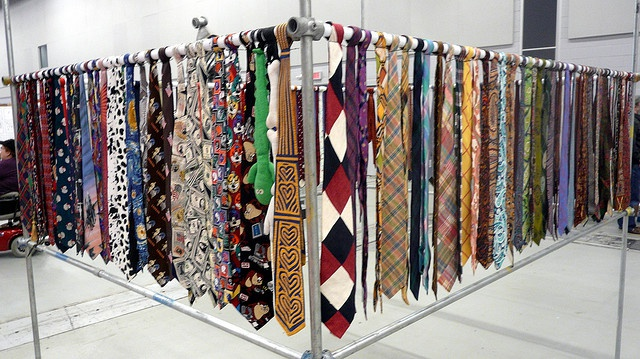Describe the objects in this image and their specific colors. I can see tie in gray, black, darkgray, and maroon tones, tie in gray, black, ivory, brown, and maroon tones, tie in gray, olive, orange, and black tones, tie in gray, black, tan, and maroon tones, and tie in gray, black, darkgray, and brown tones in this image. 